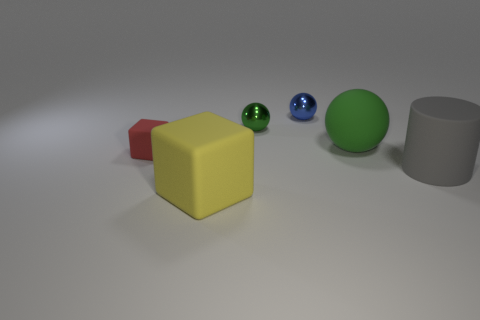Add 3 purple matte blocks. How many objects exist? 9 Subtract all cylinders. How many objects are left? 5 Subtract all big green matte objects. Subtract all gray metallic blocks. How many objects are left? 5 Add 6 green matte objects. How many green matte objects are left? 7 Add 1 small blue shiny things. How many small blue shiny things exist? 2 Subtract 0 gray spheres. How many objects are left? 6 